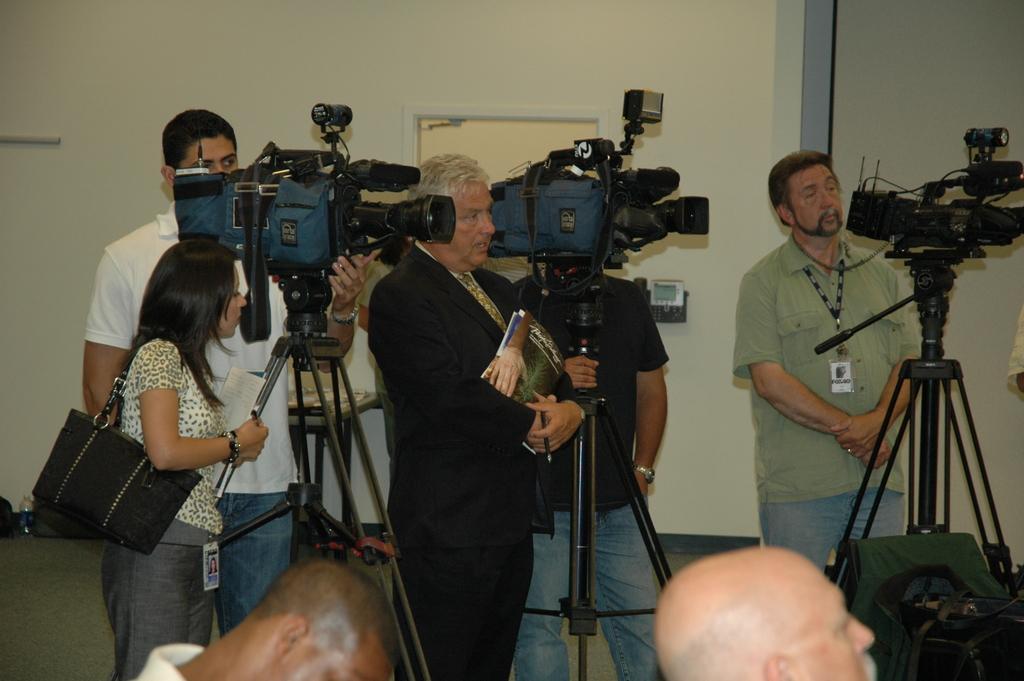Could you give a brief overview of what you see in this image? In this image I can see few people standing and few are holding cameras. One person is holding books. Back I can see a door and wall. 